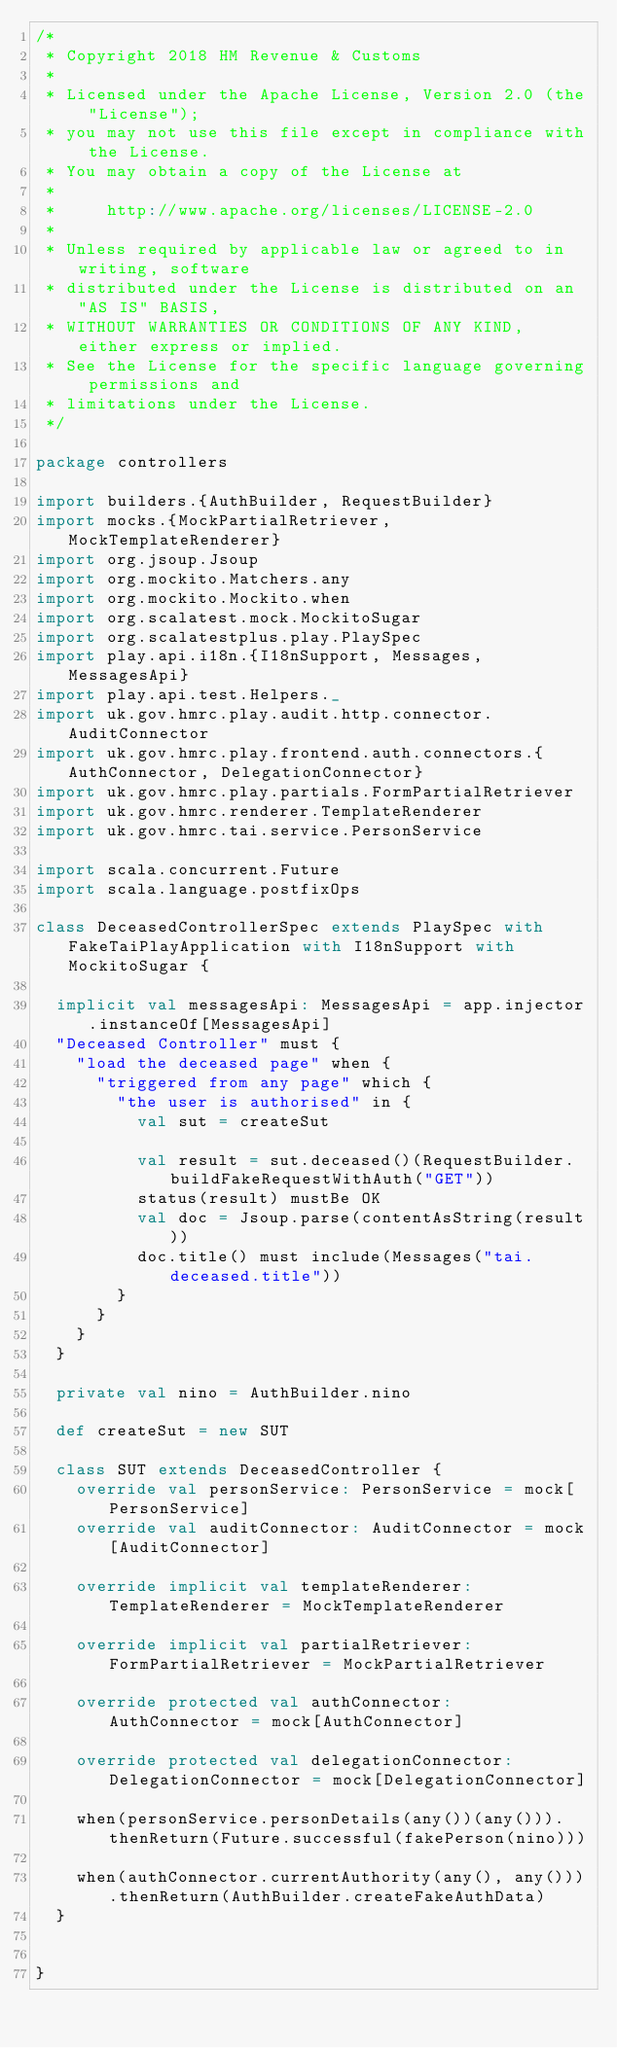Convert code to text. <code><loc_0><loc_0><loc_500><loc_500><_Scala_>/*
 * Copyright 2018 HM Revenue & Customs
 *
 * Licensed under the Apache License, Version 2.0 (the "License");
 * you may not use this file except in compliance with the License.
 * You may obtain a copy of the License at
 *
 *     http://www.apache.org/licenses/LICENSE-2.0
 *
 * Unless required by applicable law or agreed to in writing, software
 * distributed under the License is distributed on an "AS IS" BASIS,
 * WITHOUT WARRANTIES OR CONDITIONS OF ANY KIND, either express or implied.
 * See the License for the specific language governing permissions and
 * limitations under the License.
 */

package controllers

import builders.{AuthBuilder, RequestBuilder}
import mocks.{MockPartialRetriever, MockTemplateRenderer}
import org.jsoup.Jsoup
import org.mockito.Matchers.any
import org.mockito.Mockito.when
import org.scalatest.mock.MockitoSugar
import org.scalatestplus.play.PlaySpec
import play.api.i18n.{I18nSupport, Messages, MessagesApi}
import play.api.test.Helpers._
import uk.gov.hmrc.play.audit.http.connector.AuditConnector
import uk.gov.hmrc.play.frontend.auth.connectors.{AuthConnector, DelegationConnector}
import uk.gov.hmrc.play.partials.FormPartialRetriever
import uk.gov.hmrc.renderer.TemplateRenderer
import uk.gov.hmrc.tai.service.PersonService

import scala.concurrent.Future
import scala.language.postfixOps

class DeceasedControllerSpec extends PlaySpec with FakeTaiPlayApplication with I18nSupport with MockitoSugar {

  implicit val messagesApi: MessagesApi = app.injector.instanceOf[MessagesApi]
  "Deceased Controller" must {
    "load the deceased page" when {
      "triggered from any page" which {
        "the user is authorised" in {
          val sut = createSut

          val result = sut.deceased()(RequestBuilder.buildFakeRequestWithAuth("GET"))
          status(result) mustBe OK
          val doc = Jsoup.parse(contentAsString(result))
          doc.title() must include(Messages("tai.deceased.title"))
        }
      }
    }
  }

  private val nino = AuthBuilder.nino

  def createSut = new SUT

  class SUT extends DeceasedController {
    override val personService: PersonService = mock[PersonService]
    override val auditConnector: AuditConnector = mock[AuditConnector]

    override implicit val templateRenderer: TemplateRenderer = MockTemplateRenderer

    override implicit val partialRetriever: FormPartialRetriever = MockPartialRetriever

    override protected val authConnector: AuthConnector = mock[AuthConnector]

    override protected val delegationConnector: DelegationConnector = mock[DelegationConnector]

    when(personService.personDetails(any())(any())).thenReturn(Future.successful(fakePerson(nino)))

    when(authConnector.currentAuthority(any(), any())).thenReturn(AuthBuilder.createFakeAuthData)
  }


}
</code> 